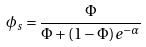Convert formula to latex. <formula><loc_0><loc_0><loc_500><loc_500>\phi _ { s } = \frac { \Phi } { \Phi + \left ( 1 - \Phi \right ) e ^ { - \alpha } }</formula> 